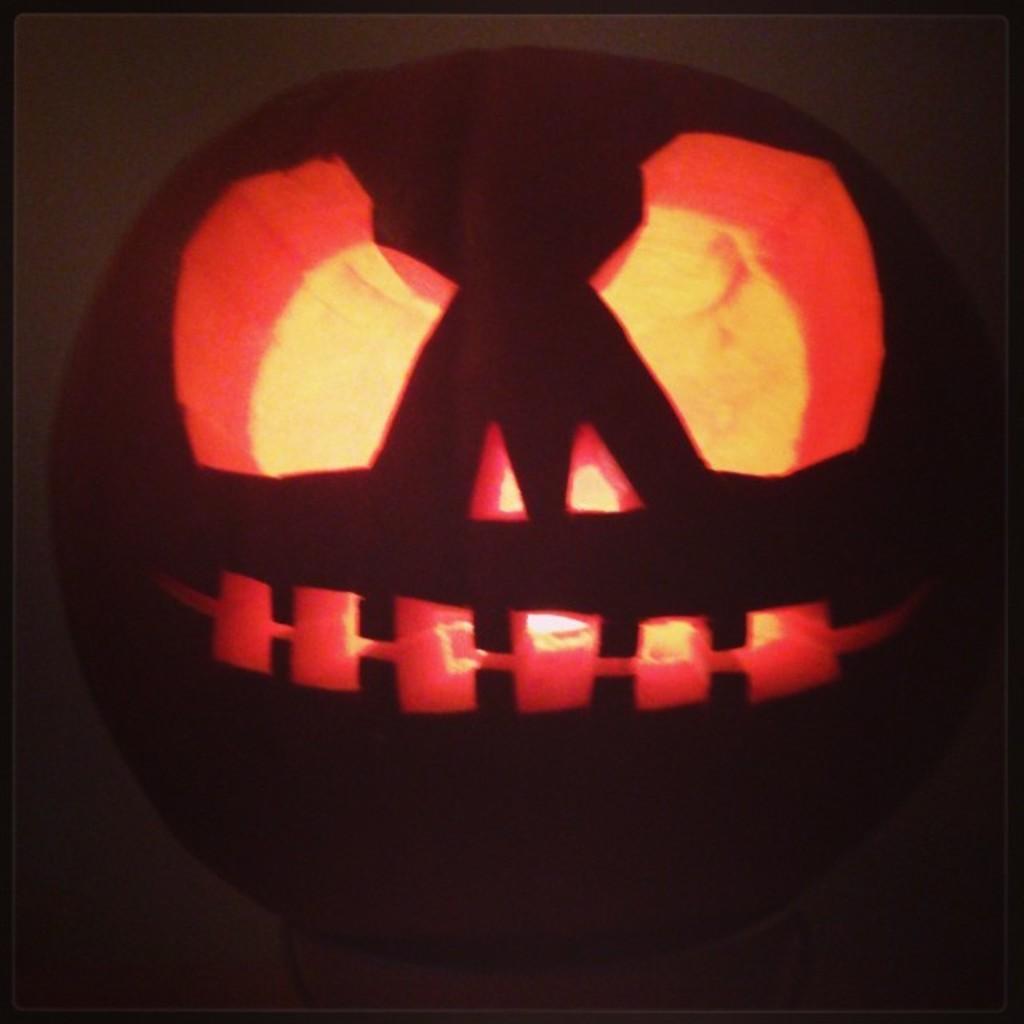Could you give a brief overview of what you see in this image? This is pumpkin. 